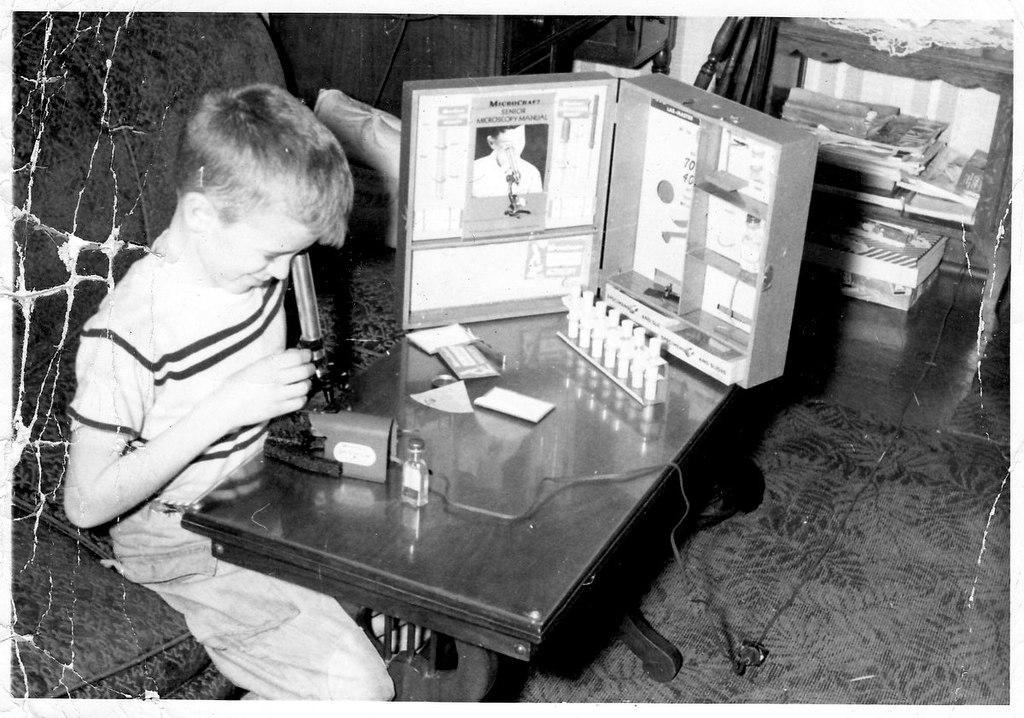Please provide a concise description of this image. Here we can see a child siting on a sofa with a table in front of him and there is a microscope through which the child is looking in to something and beside him we can see some medicine and a box present and at the top right we can see books in the rack 